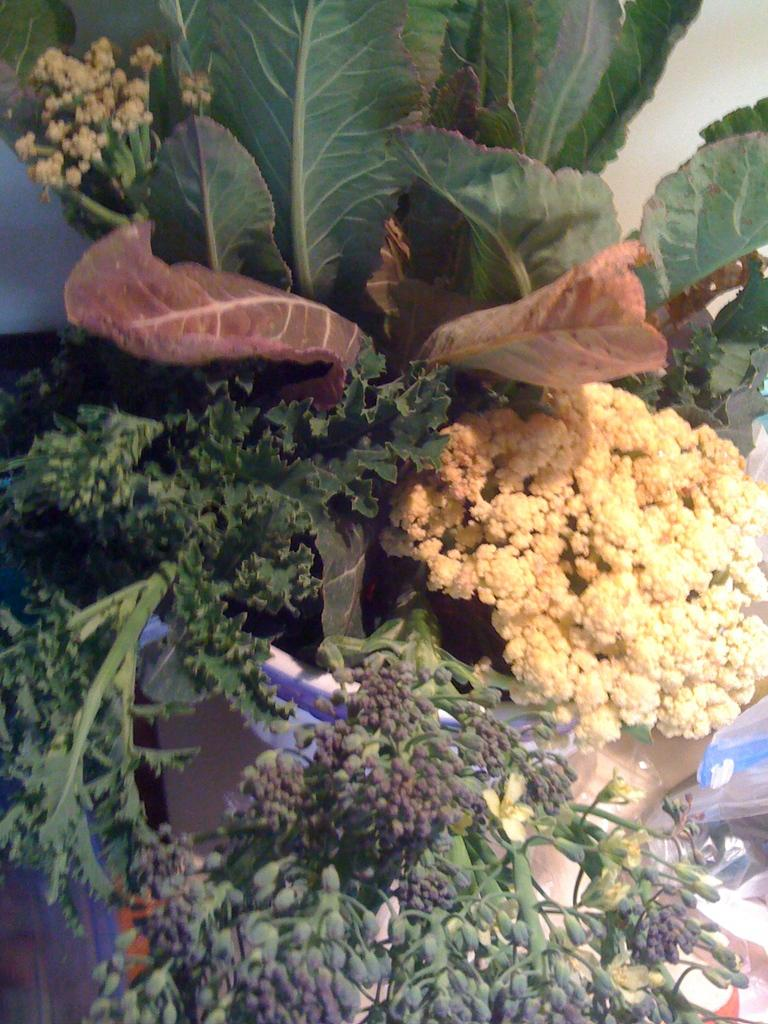What type of living organisms can be seen in the image? Plants and flowers are visible in the image. Can you describe the flowers in the image? There are flowers in the image, but their specific characteristics are not mentioned in the facts. What is visible in the background of the image? There is a table in the background of the image. What is located on the right side of the image? There is a cover on the right side of the image. How many spiders are crawling on the flowers in the image? There is no mention of spiders in the image, so we cannot determine their presence or quantity. What activity are the dolls engaged in on the table in the image? There is no mention of dolls in the image, so we cannot determine their presence or any associated activities. 